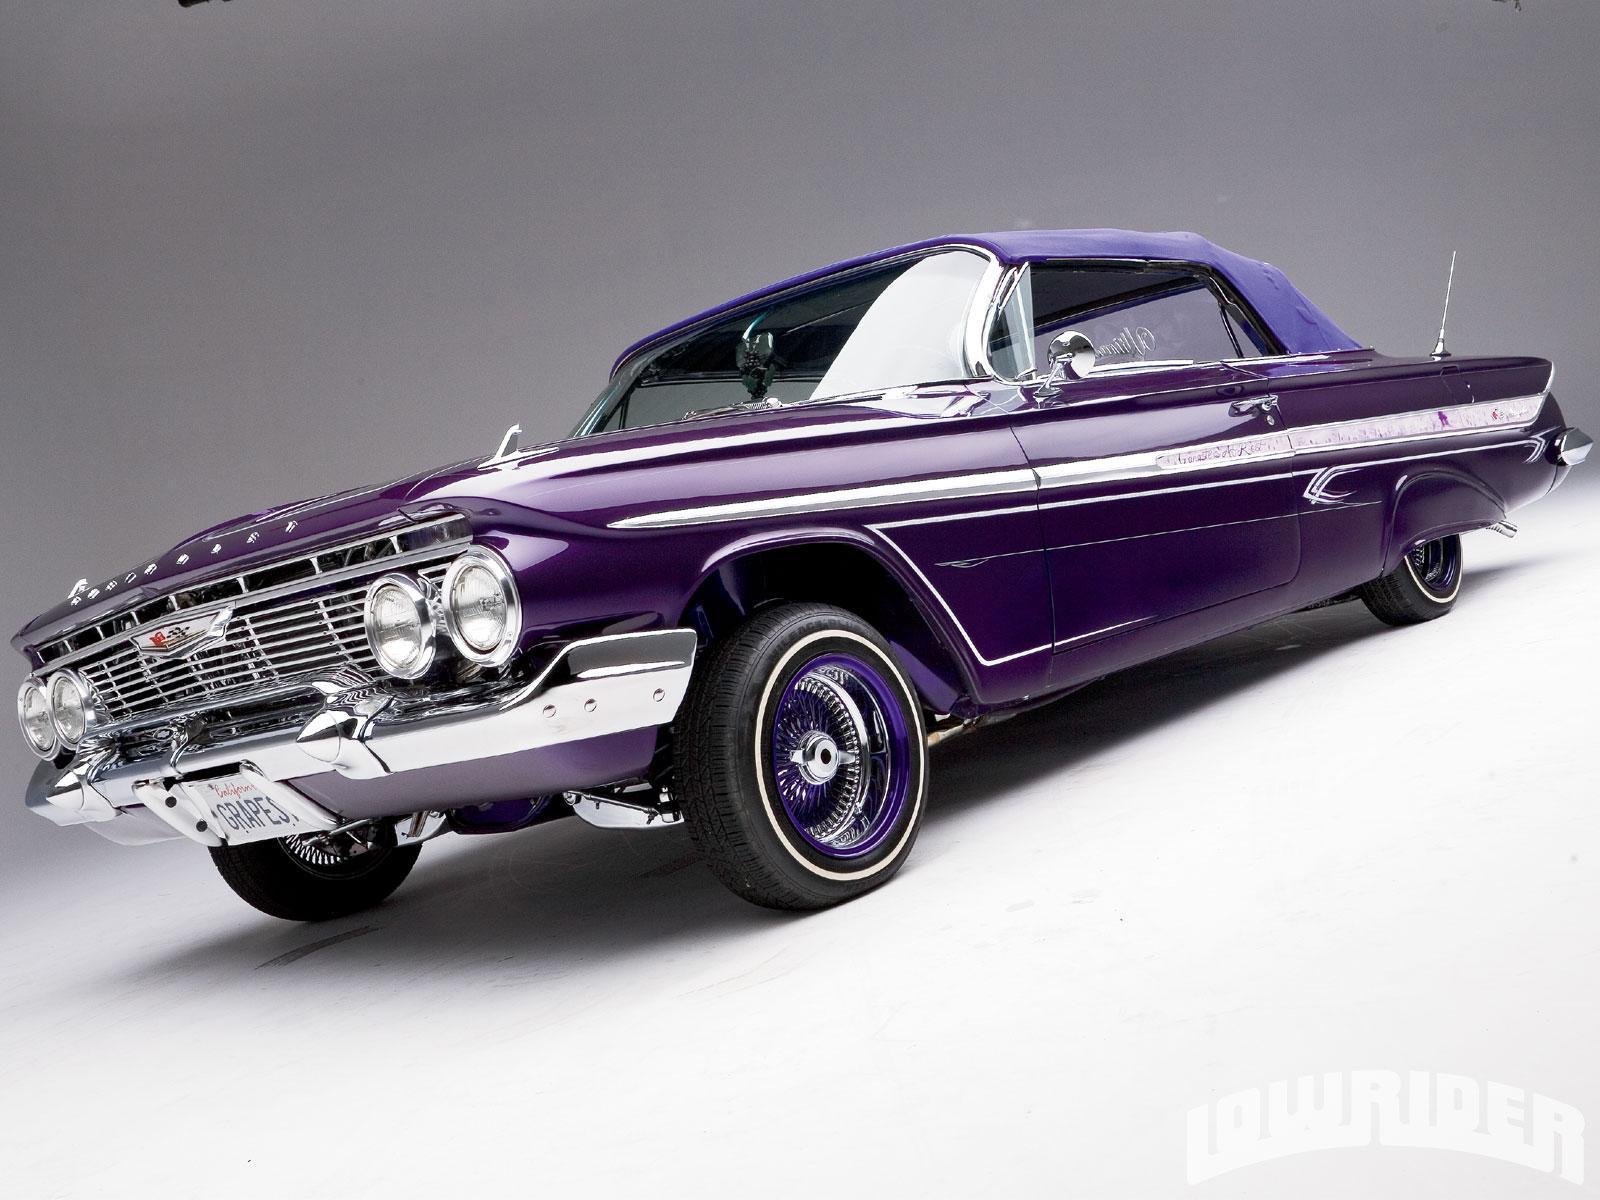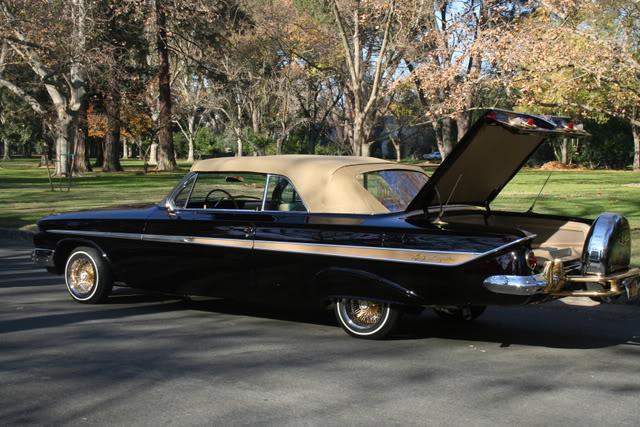The first image is the image on the left, the second image is the image on the right. Considering the images on both sides, is "In one image part of the car is open." valid? Answer yes or no. Yes. The first image is the image on the left, the second image is the image on the right. Evaluate the accuracy of this statement regarding the images: "The car in the image on the right has their convertible top open.". Is it true? Answer yes or no. No. 